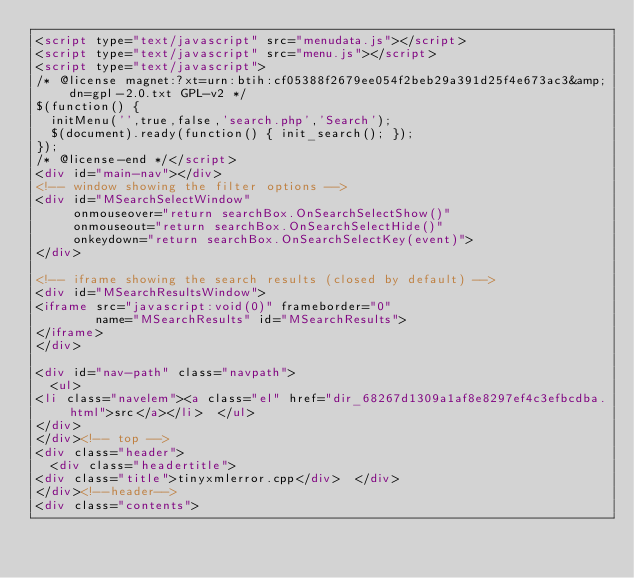Convert code to text. <code><loc_0><loc_0><loc_500><loc_500><_HTML_><script type="text/javascript" src="menudata.js"></script>
<script type="text/javascript" src="menu.js"></script>
<script type="text/javascript">
/* @license magnet:?xt=urn:btih:cf05388f2679ee054f2beb29a391d25f4e673ac3&amp;dn=gpl-2.0.txt GPL-v2 */
$(function() {
  initMenu('',true,false,'search.php','Search');
  $(document).ready(function() { init_search(); });
});
/* @license-end */</script>
<div id="main-nav"></div>
<!-- window showing the filter options -->
<div id="MSearchSelectWindow"
     onmouseover="return searchBox.OnSearchSelectShow()"
     onmouseout="return searchBox.OnSearchSelectHide()"
     onkeydown="return searchBox.OnSearchSelectKey(event)">
</div>

<!-- iframe showing the search results (closed by default) -->
<div id="MSearchResultsWindow">
<iframe src="javascript:void(0)" frameborder="0" 
        name="MSearchResults" id="MSearchResults">
</iframe>
</div>

<div id="nav-path" class="navpath">
  <ul>
<li class="navelem"><a class="el" href="dir_68267d1309a1af8e8297ef4c3efbcdba.html">src</a></li>  </ul>
</div>
</div><!-- top -->
<div class="header">
  <div class="headertitle">
<div class="title">tinyxmlerror.cpp</div>  </div>
</div><!--header-->
<div class="contents"></code> 